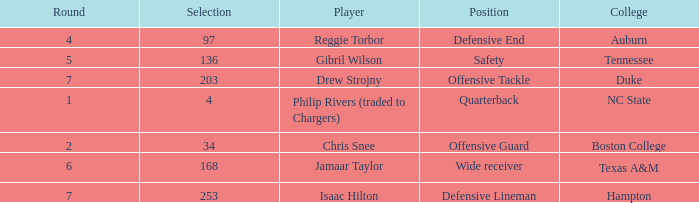Which Selection has a College of texas a&m? 168.0. 